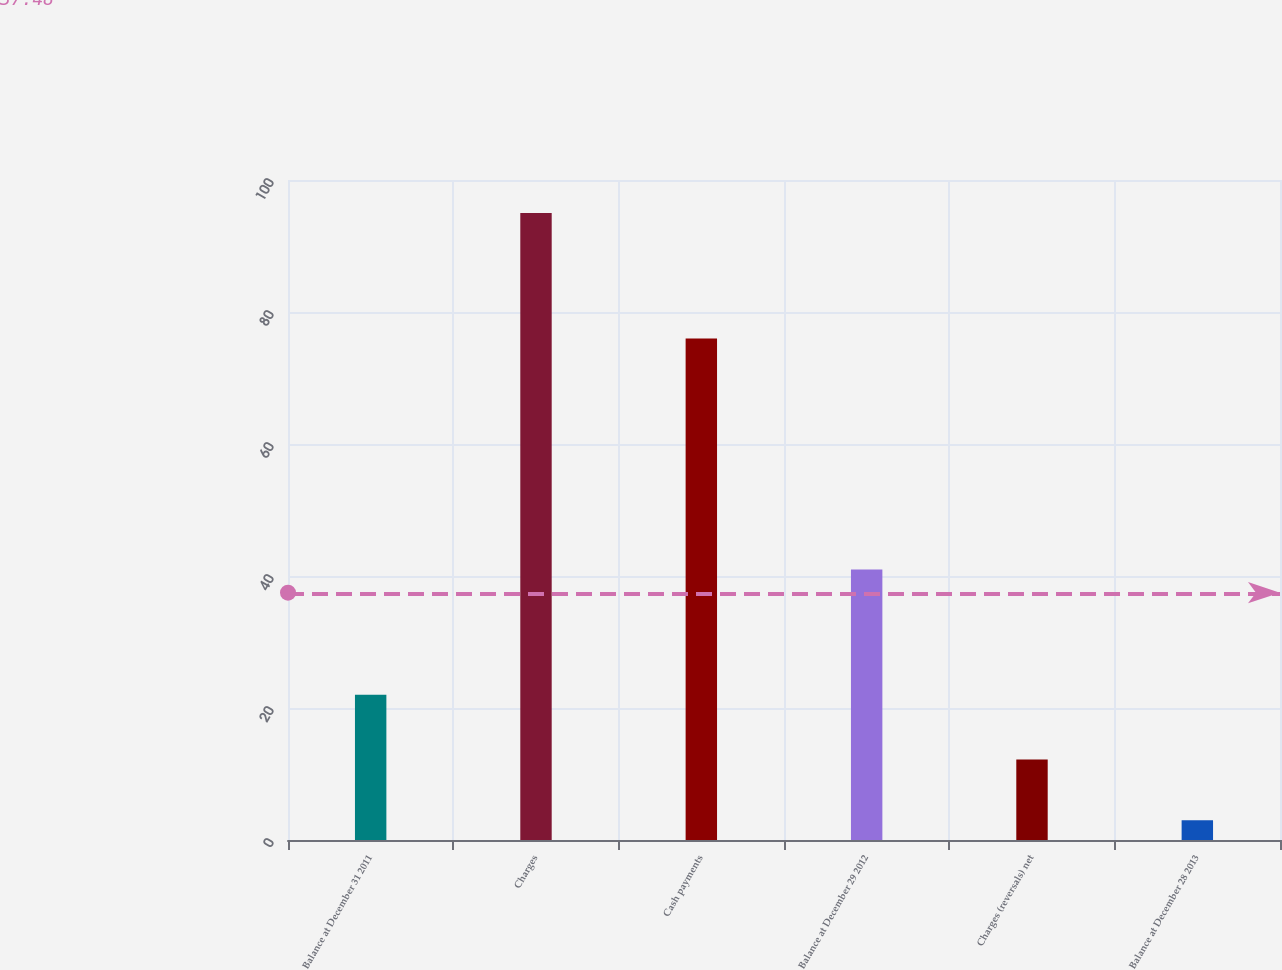<chart> <loc_0><loc_0><loc_500><loc_500><bar_chart><fcel>Balance at December 31 2011<fcel>Charges<fcel>Cash payments<fcel>Balance at December 29 2012<fcel>Charges (reversals) net<fcel>Balance at December 28 2013<nl><fcel>22<fcel>95<fcel>76<fcel>41<fcel>12.2<fcel>3<nl></chart> 